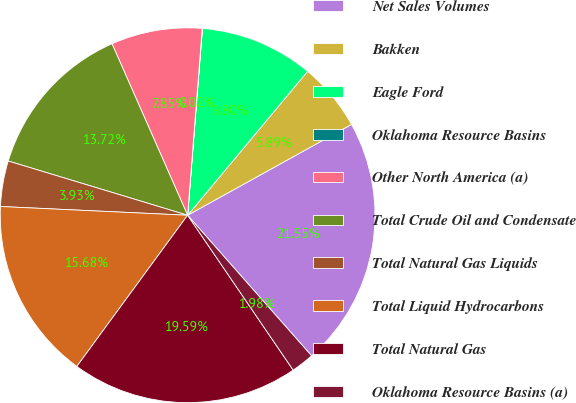Convert chart. <chart><loc_0><loc_0><loc_500><loc_500><pie_chart><fcel>Net Sales Volumes<fcel>Bakken<fcel>Eagle Ford<fcel>Oklahoma Resource Basins<fcel>Other North America (a)<fcel>Total Crude Oil and Condensate<fcel>Total Natural Gas Liquids<fcel>Total Liquid Hydrocarbons<fcel>Total Natural Gas<fcel>Oklahoma Resource Basins (a)<nl><fcel>21.55%<fcel>5.89%<fcel>9.8%<fcel>0.02%<fcel>7.85%<fcel>13.72%<fcel>3.93%<fcel>15.68%<fcel>19.59%<fcel>1.98%<nl></chart> 